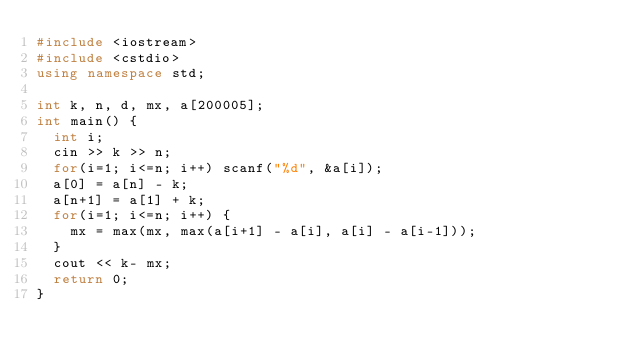<code> <loc_0><loc_0><loc_500><loc_500><_C++_>#include <iostream>
#include <cstdio>
using namespace std;

int k, n, d, mx, a[200005];
int main() {
	int i;
	cin >> k >> n;
	for(i=1; i<=n; i++) scanf("%d", &a[i]);
	a[0] = a[n] - k;
	a[n+1] = a[1] + k;
	for(i=1; i<=n; i++) {
		mx = max(mx, max(a[i+1] - a[i], a[i] - a[i-1]));
	}
	cout << k- mx;
	return 0;
}</code> 